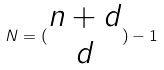Convert formula to latex. <formula><loc_0><loc_0><loc_500><loc_500>N = ( \begin{matrix} n + d \\ d \end{matrix} ) - 1</formula> 